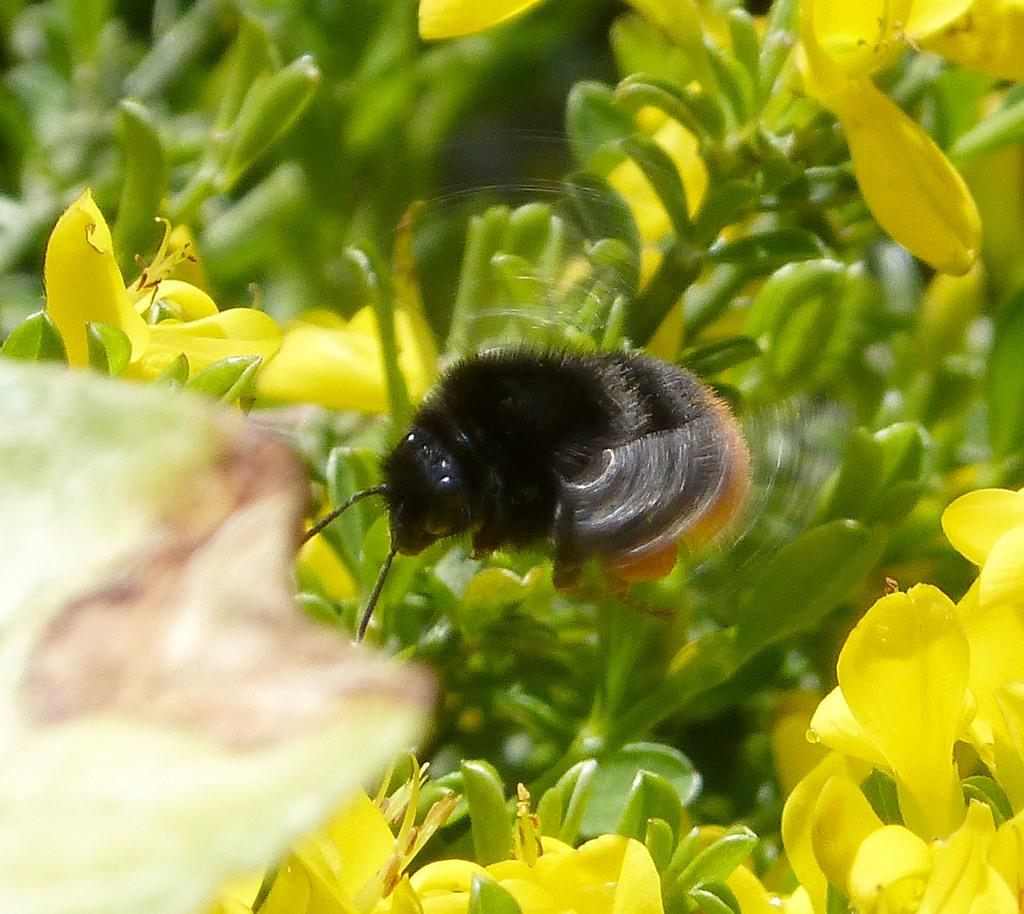What type of plants can be seen in the image? There are plants with flowers in the image. What color are the flowers on the plants? The flowers are yellow in color. What other living creature can be seen in the image? There is a bug in the image. What colors can be observed on the bug? The bug is black in color, and it has some brown color on it. What type of yam is being harvested in the image? There is no yam present in the image. 